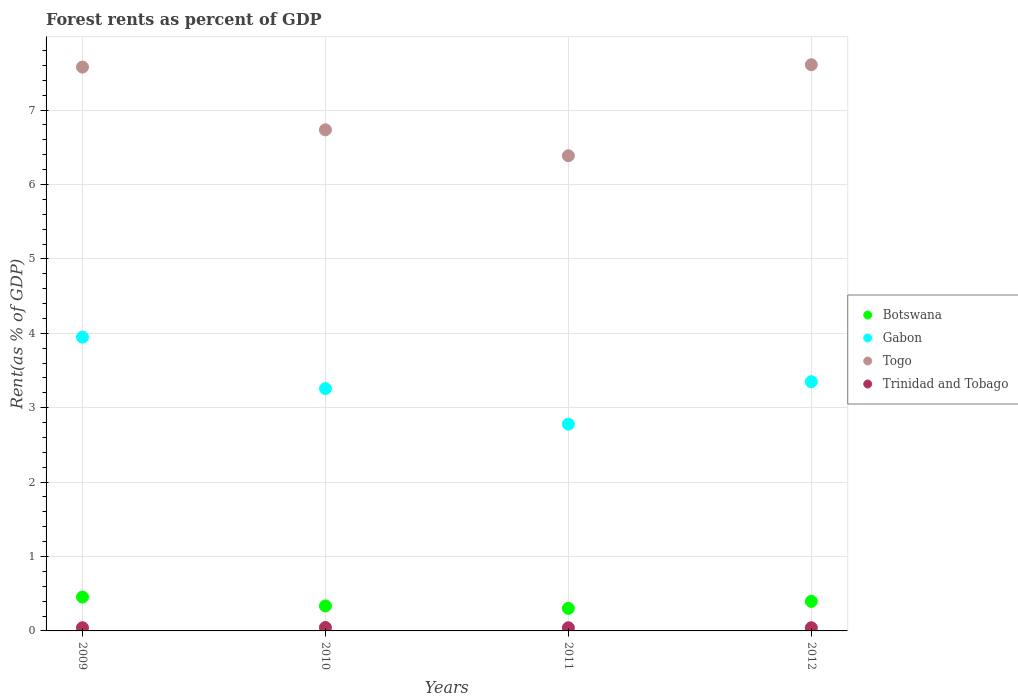How many different coloured dotlines are there?
Your response must be concise. 4. Is the number of dotlines equal to the number of legend labels?
Keep it short and to the point. Yes. What is the forest rent in Gabon in 2009?
Ensure brevity in your answer.  3.95. Across all years, what is the maximum forest rent in Trinidad and Tobago?
Provide a short and direct response. 0.05. Across all years, what is the minimum forest rent in Botswana?
Provide a succinct answer. 0.3. In which year was the forest rent in Botswana minimum?
Provide a short and direct response. 2011. What is the total forest rent in Trinidad and Tobago in the graph?
Keep it short and to the point. 0.18. What is the difference between the forest rent in Togo in 2010 and that in 2011?
Your answer should be very brief. 0.35. What is the difference between the forest rent in Botswana in 2011 and the forest rent in Gabon in 2012?
Keep it short and to the point. -3.05. What is the average forest rent in Togo per year?
Ensure brevity in your answer.  7.08. In the year 2010, what is the difference between the forest rent in Botswana and forest rent in Trinidad and Tobago?
Ensure brevity in your answer.  0.29. In how many years, is the forest rent in Botswana greater than 4.6 %?
Provide a short and direct response. 0. What is the ratio of the forest rent in Gabon in 2010 to that in 2012?
Make the answer very short. 0.97. What is the difference between the highest and the second highest forest rent in Togo?
Your answer should be very brief. 0.03. What is the difference between the highest and the lowest forest rent in Gabon?
Offer a very short reply. 1.17. Does the forest rent in Trinidad and Tobago monotonically increase over the years?
Offer a terse response. No. Is the forest rent in Gabon strictly greater than the forest rent in Togo over the years?
Keep it short and to the point. No. Is the forest rent in Botswana strictly less than the forest rent in Gabon over the years?
Keep it short and to the point. Yes. What is the difference between two consecutive major ticks on the Y-axis?
Offer a terse response. 1. Are the values on the major ticks of Y-axis written in scientific E-notation?
Offer a very short reply. No. Where does the legend appear in the graph?
Give a very brief answer. Center right. How are the legend labels stacked?
Your answer should be compact. Vertical. What is the title of the graph?
Make the answer very short. Forest rents as percent of GDP. Does "Chad" appear as one of the legend labels in the graph?
Provide a short and direct response. No. What is the label or title of the Y-axis?
Offer a very short reply. Rent(as % of GDP). What is the Rent(as % of GDP) of Botswana in 2009?
Provide a short and direct response. 0.46. What is the Rent(as % of GDP) of Gabon in 2009?
Provide a short and direct response. 3.95. What is the Rent(as % of GDP) in Togo in 2009?
Ensure brevity in your answer.  7.58. What is the Rent(as % of GDP) of Trinidad and Tobago in 2009?
Make the answer very short. 0.04. What is the Rent(as % of GDP) in Botswana in 2010?
Make the answer very short. 0.34. What is the Rent(as % of GDP) of Gabon in 2010?
Offer a terse response. 3.26. What is the Rent(as % of GDP) of Togo in 2010?
Your response must be concise. 6.74. What is the Rent(as % of GDP) of Trinidad and Tobago in 2010?
Your response must be concise. 0.05. What is the Rent(as % of GDP) in Botswana in 2011?
Your answer should be very brief. 0.3. What is the Rent(as % of GDP) in Gabon in 2011?
Offer a terse response. 2.78. What is the Rent(as % of GDP) in Togo in 2011?
Offer a terse response. 6.39. What is the Rent(as % of GDP) in Trinidad and Tobago in 2011?
Offer a very short reply. 0.04. What is the Rent(as % of GDP) in Botswana in 2012?
Your answer should be compact. 0.4. What is the Rent(as % of GDP) in Gabon in 2012?
Offer a very short reply. 3.35. What is the Rent(as % of GDP) in Togo in 2012?
Give a very brief answer. 7.61. What is the Rent(as % of GDP) in Trinidad and Tobago in 2012?
Give a very brief answer. 0.04. Across all years, what is the maximum Rent(as % of GDP) in Botswana?
Your response must be concise. 0.46. Across all years, what is the maximum Rent(as % of GDP) of Gabon?
Give a very brief answer. 3.95. Across all years, what is the maximum Rent(as % of GDP) of Togo?
Provide a short and direct response. 7.61. Across all years, what is the maximum Rent(as % of GDP) in Trinidad and Tobago?
Give a very brief answer. 0.05. Across all years, what is the minimum Rent(as % of GDP) in Botswana?
Keep it short and to the point. 0.3. Across all years, what is the minimum Rent(as % of GDP) in Gabon?
Keep it short and to the point. 2.78. Across all years, what is the minimum Rent(as % of GDP) in Togo?
Offer a terse response. 6.39. Across all years, what is the minimum Rent(as % of GDP) in Trinidad and Tobago?
Offer a terse response. 0.04. What is the total Rent(as % of GDP) in Botswana in the graph?
Make the answer very short. 1.49. What is the total Rent(as % of GDP) in Gabon in the graph?
Ensure brevity in your answer.  13.33. What is the total Rent(as % of GDP) of Togo in the graph?
Offer a very short reply. 28.31. What is the total Rent(as % of GDP) in Trinidad and Tobago in the graph?
Provide a short and direct response. 0.18. What is the difference between the Rent(as % of GDP) of Botswana in 2009 and that in 2010?
Provide a succinct answer. 0.12. What is the difference between the Rent(as % of GDP) of Gabon in 2009 and that in 2010?
Provide a short and direct response. 0.69. What is the difference between the Rent(as % of GDP) of Togo in 2009 and that in 2010?
Give a very brief answer. 0.84. What is the difference between the Rent(as % of GDP) in Trinidad and Tobago in 2009 and that in 2010?
Ensure brevity in your answer.  -0. What is the difference between the Rent(as % of GDP) in Botswana in 2009 and that in 2011?
Give a very brief answer. 0.15. What is the difference between the Rent(as % of GDP) in Gabon in 2009 and that in 2011?
Keep it short and to the point. 1.17. What is the difference between the Rent(as % of GDP) of Togo in 2009 and that in 2011?
Give a very brief answer. 1.19. What is the difference between the Rent(as % of GDP) in Trinidad and Tobago in 2009 and that in 2011?
Ensure brevity in your answer.  0. What is the difference between the Rent(as % of GDP) of Botswana in 2009 and that in 2012?
Provide a succinct answer. 0.06. What is the difference between the Rent(as % of GDP) of Gabon in 2009 and that in 2012?
Your answer should be very brief. 0.6. What is the difference between the Rent(as % of GDP) in Togo in 2009 and that in 2012?
Give a very brief answer. -0.03. What is the difference between the Rent(as % of GDP) of Trinidad and Tobago in 2009 and that in 2012?
Make the answer very short. 0. What is the difference between the Rent(as % of GDP) in Botswana in 2010 and that in 2011?
Provide a succinct answer. 0.03. What is the difference between the Rent(as % of GDP) of Gabon in 2010 and that in 2011?
Offer a very short reply. 0.48. What is the difference between the Rent(as % of GDP) of Togo in 2010 and that in 2011?
Make the answer very short. 0.35. What is the difference between the Rent(as % of GDP) of Trinidad and Tobago in 2010 and that in 2011?
Your answer should be compact. 0. What is the difference between the Rent(as % of GDP) in Botswana in 2010 and that in 2012?
Provide a succinct answer. -0.06. What is the difference between the Rent(as % of GDP) in Gabon in 2010 and that in 2012?
Offer a very short reply. -0.09. What is the difference between the Rent(as % of GDP) in Togo in 2010 and that in 2012?
Your response must be concise. -0.87. What is the difference between the Rent(as % of GDP) of Trinidad and Tobago in 2010 and that in 2012?
Your answer should be compact. 0. What is the difference between the Rent(as % of GDP) in Botswana in 2011 and that in 2012?
Your answer should be compact. -0.09. What is the difference between the Rent(as % of GDP) of Gabon in 2011 and that in 2012?
Provide a succinct answer. -0.57. What is the difference between the Rent(as % of GDP) of Togo in 2011 and that in 2012?
Ensure brevity in your answer.  -1.22. What is the difference between the Rent(as % of GDP) of Trinidad and Tobago in 2011 and that in 2012?
Offer a terse response. -0. What is the difference between the Rent(as % of GDP) in Botswana in 2009 and the Rent(as % of GDP) in Gabon in 2010?
Provide a succinct answer. -2.8. What is the difference between the Rent(as % of GDP) of Botswana in 2009 and the Rent(as % of GDP) of Togo in 2010?
Offer a very short reply. -6.28. What is the difference between the Rent(as % of GDP) in Botswana in 2009 and the Rent(as % of GDP) in Trinidad and Tobago in 2010?
Ensure brevity in your answer.  0.41. What is the difference between the Rent(as % of GDP) of Gabon in 2009 and the Rent(as % of GDP) of Togo in 2010?
Your answer should be compact. -2.79. What is the difference between the Rent(as % of GDP) in Gabon in 2009 and the Rent(as % of GDP) in Trinidad and Tobago in 2010?
Ensure brevity in your answer.  3.9. What is the difference between the Rent(as % of GDP) in Togo in 2009 and the Rent(as % of GDP) in Trinidad and Tobago in 2010?
Ensure brevity in your answer.  7.53. What is the difference between the Rent(as % of GDP) of Botswana in 2009 and the Rent(as % of GDP) of Gabon in 2011?
Your answer should be compact. -2.32. What is the difference between the Rent(as % of GDP) in Botswana in 2009 and the Rent(as % of GDP) in Togo in 2011?
Keep it short and to the point. -5.93. What is the difference between the Rent(as % of GDP) of Botswana in 2009 and the Rent(as % of GDP) of Trinidad and Tobago in 2011?
Keep it short and to the point. 0.41. What is the difference between the Rent(as % of GDP) in Gabon in 2009 and the Rent(as % of GDP) in Togo in 2011?
Offer a very short reply. -2.44. What is the difference between the Rent(as % of GDP) in Gabon in 2009 and the Rent(as % of GDP) in Trinidad and Tobago in 2011?
Keep it short and to the point. 3.91. What is the difference between the Rent(as % of GDP) of Togo in 2009 and the Rent(as % of GDP) of Trinidad and Tobago in 2011?
Offer a very short reply. 7.54. What is the difference between the Rent(as % of GDP) in Botswana in 2009 and the Rent(as % of GDP) in Gabon in 2012?
Keep it short and to the point. -2.89. What is the difference between the Rent(as % of GDP) in Botswana in 2009 and the Rent(as % of GDP) in Togo in 2012?
Ensure brevity in your answer.  -7.15. What is the difference between the Rent(as % of GDP) of Botswana in 2009 and the Rent(as % of GDP) of Trinidad and Tobago in 2012?
Your answer should be compact. 0.41. What is the difference between the Rent(as % of GDP) of Gabon in 2009 and the Rent(as % of GDP) of Togo in 2012?
Provide a succinct answer. -3.66. What is the difference between the Rent(as % of GDP) of Gabon in 2009 and the Rent(as % of GDP) of Trinidad and Tobago in 2012?
Offer a very short reply. 3.91. What is the difference between the Rent(as % of GDP) of Togo in 2009 and the Rent(as % of GDP) of Trinidad and Tobago in 2012?
Offer a very short reply. 7.54. What is the difference between the Rent(as % of GDP) of Botswana in 2010 and the Rent(as % of GDP) of Gabon in 2011?
Offer a very short reply. -2.44. What is the difference between the Rent(as % of GDP) in Botswana in 2010 and the Rent(as % of GDP) in Togo in 2011?
Keep it short and to the point. -6.05. What is the difference between the Rent(as % of GDP) in Botswana in 2010 and the Rent(as % of GDP) in Trinidad and Tobago in 2011?
Your response must be concise. 0.29. What is the difference between the Rent(as % of GDP) of Gabon in 2010 and the Rent(as % of GDP) of Togo in 2011?
Your response must be concise. -3.13. What is the difference between the Rent(as % of GDP) of Gabon in 2010 and the Rent(as % of GDP) of Trinidad and Tobago in 2011?
Ensure brevity in your answer.  3.21. What is the difference between the Rent(as % of GDP) of Togo in 2010 and the Rent(as % of GDP) of Trinidad and Tobago in 2011?
Provide a succinct answer. 6.69. What is the difference between the Rent(as % of GDP) of Botswana in 2010 and the Rent(as % of GDP) of Gabon in 2012?
Make the answer very short. -3.01. What is the difference between the Rent(as % of GDP) of Botswana in 2010 and the Rent(as % of GDP) of Togo in 2012?
Make the answer very short. -7.27. What is the difference between the Rent(as % of GDP) of Botswana in 2010 and the Rent(as % of GDP) of Trinidad and Tobago in 2012?
Your response must be concise. 0.29. What is the difference between the Rent(as % of GDP) of Gabon in 2010 and the Rent(as % of GDP) of Togo in 2012?
Your answer should be compact. -4.35. What is the difference between the Rent(as % of GDP) in Gabon in 2010 and the Rent(as % of GDP) in Trinidad and Tobago in 2012?
Provide a succinct answer. 3.21. What is the difference between the Rent(as % of GDP) in Togo in 2010 and the Rent(as % of GDP) in Trinidad and Tobago in 2012?
Keep it short and to the point. 6.69. What is the difference between the Rent(as % of GDP) of Botswana in 2011 and the Rent(as % of GDP) of Gabon in 2012?
Make the answer very short. -3.05. What is the difference between the Rent(as % of GDP) of Botswana in 2011 and the Rent(as % of GDP) of Togo in 2012?
Make the answer very short. -7.31. What is the difference between the Rent(as % of GDP) of Botswana in 2011 and the Rent(as % of GDP) of Trinidad and Tobago in 2012?
Keep it short and to the point. 0.26. What is the difference between the Rent(as % of GDP) in Gabon in 2011 and the Rent(as % of GDP) in Togo in 2012?
Provide a short and direct response. -4.83. What is the difference between the Rent(as % of GDP) in Gabon in 2011 and the Rent(as % of GDP) in Trinidad and Tobago in 2012?
Your answer should be compact. 2.74. What is the difference between the Rent(as % of GDP) in Togo in 2011 and the Rent(as % of GDP) in Trinidad and Tobago in 2012?
Give a very brief answer. 6.34. What is the average Rent(as % of GDP) of Botswana per year?
Provide a short and direct response. 0.37. What is the average Rent(as % of GDP) of Gabon per year?
Give a very brief answer. 3.33. What is the average Rent(as % of GDP) in Togo per year?
Offer a very short reply. 7.08. What is the average Rent(as % of GDP) of Trinidad and Tobago per year?
Offer a very short reply. 0.04. In the year 2009, what is the difference between the Rent(as % of GDP) of Botswana and Rent(as % of GDP) of Gabon?
Your answer should be very brief. -3.49. In the year 2009, what is the difference between the Rent(as % of GDP) of Botswana and Rent(as % of GDP) of Togo?
Your answer should be very brief. -7.12. In the year 2009, what is the difference between the Rent(as % of GDP) in Botswana and Rent(as % of GDP) in Trinidad and Tobago?
Provide a short and direct response. 0.41. In the year 2009, what is the difference between the Rent(as % of GDP) of Gabon and Rent(as % of GDP) of Togo?
Offer a very short reply. -3.63. In the year 2009, what is the difference between the Rent(as % of GDP) of Gabon and Rent(as % of GDP) of Trinidad and Tobago?
Your answer should be compact. 3.91. In the year 2009, what is the difference between the Rent(as % of GDP) of Togo and Rent(as % of GDP) of Trinidad and Tobago?
Provide a short and direct response. 7.53. In the year 2010, what is the difference between the Rent(as % of GDP) in Botswana and Rent(as % of GDP) in Gabon?
Ensure brevity in your answer.  -2.92. In the year 2010, what is the difference between the Rent(as % of GDP) in Botswana and Rent(as % of GDP) in Togo?
Your response must be concise. -6.4. In the year 2010, what is the difference between the Rent(as % of GDP) in Botswana and Rent(as % of GDP) in Trinidad and Tobago?
Make the answer very short. 0.29. In the year 2010, what is the difference between the Rent(as % of GDP) in Gabon and Rent(as % of GDP) in Togo?
Provide a short and direct response. -3.48. In the year 2010, what is the difference between the Rent(as % of GDP) in Gabon and Rent(as % of GDP) in Trinidad and Tobago?
Provide a short and direct response. 3.21. In the year 2010, what is the difference between the Rent(as % of GDP) in Togo and Rent(as % of GDP) in Trinidad and Tobago?
Keep it short and to the point. 6.69. In the year 2011, what is the difference between the Rent(as % of GDP) in Botswana and Rent(as % of GDP) in Gabon?
Provide a succinct answer. -2.48. In the year 2011, what is the difference between the Rent(as % of GDP) in Botswana and Rent(as % of GDP) in Togo?
Your answer should be compact. -6.08. In the year 2011, what is the difference between the Rent(as % of GDP) of Botswana and Rent(as % of GDP) of Trinidad and Tobago?
Your answer should be compact. 0.26. In the year 2011, what is the difference between the Rent(as % of GDP) of Gabon and Rent(as % of GDP) of Togo?
Provide a succinct answer. -3.61. In the year 2011, what is the difference between the Rent(as % of GDP) of Gabon and Rent(as % of GDP) of Trinidad and Tobago?
Offer a terse response. 2.74. In the year 2011, what is the difference between the Rent(as % of GDP) in Togo and Rent(as % of GDP) in Trinidad and Tobago?
Ensure brevity in your answer.  6.34. In the year 2012, what is the difference between the Rent(as % of GDP) of Botswana and Rent(as % of GDP) of Gabon?
Your answer should be compact. -2.95. In the year 2012, what is the difference between the Rent(as % of GDP) in Botswana and Rent(as % of GDP) in Togo?
Keep it short and to the point. -7.21. In the year 2012, what is the difference between the Rent(as % of GDP) in Botswana and Rent(as % of GDP) in Trinidad and Tobago?
Your response must be concise. 0.35. In the year 2012, what is the difference between the Rent(as % of GDP) in Gabon and Rent(as % of GDP) in Togo?
Offer a very short reply. -4.26. In the year 2012, what is the difference between the Rent(as % of GDP) in Gabon and Rent(as % of GDP) in Trinidad and Tobago?
Ensure brevity in your answer.  3.31. In the year 2012, what is the difference between the Rent(as % of GDP) of Togo and Rent(as % of GDP) of Trinidad and Tobago?
Provide a short and direct response. 7.57. What is the ratio of the Rent(as % of GDP) in Botswana in 2009 to that in 2010?
Your answer should be very brief. 1.36. What is the ratio of the Rent(as % of GDP) in Gabon in 2009 to that in 2010?
Give a very brief answer. 1.21. What is the ratio of the Rent(as % of GDP) of Togo in 2009 to that in 2010?
Keep it short and to the point. 1.13. What is the ratio of the Rent(as % of GDP) of Trinidad and Tobago in 2009 to that in 2010?
Make the answer very short. 0.93. What is the ratio of the Rent(as % of GDP) in Botswana in 2009 to that in 2011?
Your response must be concise. 1.5. What is the ratio of the Rent(as % of GDP) of Gabon in 2009 to that in 2011?
Ensure brevity in your answer.  1.42. What is the ratio of the Rent(as % of GDP) of Togo in 2009 to that in 2011?
Your answer should be very brief. 1.19. What is the ratio of the Rent(as % of GDP) in Trinidad and Tobago in 2009 to that in 2011?
Your answer should be very brief. 1.02. What is the ratio of the Rent(as % of GDP) in Botswana in 2009 to that in 2012?
Give a very brief answer. 1.15. What is the ratio of the Rent(as % of GDP) of Gabon in 2009 to that in 2012?
Provide a short and direct response. 1.18. What is the ratio of the Rent(as % of GDP) in Trinidad and Tobago in 2009 to that in 2012?
Your answer should be compact. 1.01. What is the ratio of the Rent(as % of GDP) in Botswana in 2010 to that in 2011?
Provide a short and direct response. 1.11. What is the ratio of the Rent(as % of GDP) of Gabon in 2010 to that in 2011?
Provide a succinct answer. 1.17. What is the ratio of the Rent(as % of GDP) in Togo in 2010 to that in 2011?
Keep it short and to the point. 1.05. What is the ratio of the Rent(as % of GDP) in Trinidad and Tobago in 2010 to that in 2011?
Offer a terse response. 1.09. What is the ratio of the Rent(as % of GDP) of Botswana in 2010 to that in 2012?
Offer a very short reply. 0.85. What is the ratio of the Rent(as % of GDP) in Gabon in 2010 to that in 2012?
Offer a terse response. 0.97. What is the ratio of the Rent(as % of GDP) in Togo in 2010 to that in 2012?
Keep it short and to the point. 0.89. What is the ratio of the Rent(as % of GDP) of Trinidad and Tobago in 2010 to that in 2012?
Your answer should be compact. 1.08. What is the ratio of the Rent(as % of GDP) in Botswana in 2011 to that in 2012?
Ensure brevity in your answer.  0.76. What is the ratio of the Rent(as % of GDP) of Gabon in 2011 to that in 2012?
Offer a terse response. 0.83. What is the ratio of the Rent(as % of GDP) of Togo in 2011 to that in 2012?
Provide a short and direct response. 0.84. What is the difference between the highest and the second highest Rent(as % of GDP) of Botswana?
Your answer should be very brief. 0.06. What is the difference between the highest and the second highest Rent(as % of GDP) of Gabon?
Make the answer very short. 0.6. What is the difference between the highest and the second highest Rent(as % of GDP) of Togo?
Provide a short and direct response. 0.03. What is the difference between the highest and the second highest Rent(as % of GDP) in Trinidad and Tobago?
Your response must be concise. 0. What is the difference between the highest and the lowest Rent(as % of GDP) of Botswana?
Offer a terse response. 0.15. What is the difference between the highest and the lowest Rent(as % of GDP) in Gabon?
Ensure brevity in your answer.  1.17. What is the difference between the highest and the lowest Rent(as % of GDP) in Togo?
Give a very brief answer. 1.22. What is the difference between the highest and the lowest Rent(as % of GDP) of Trinidad and Tobago?
Give a very brief answer. 0. 